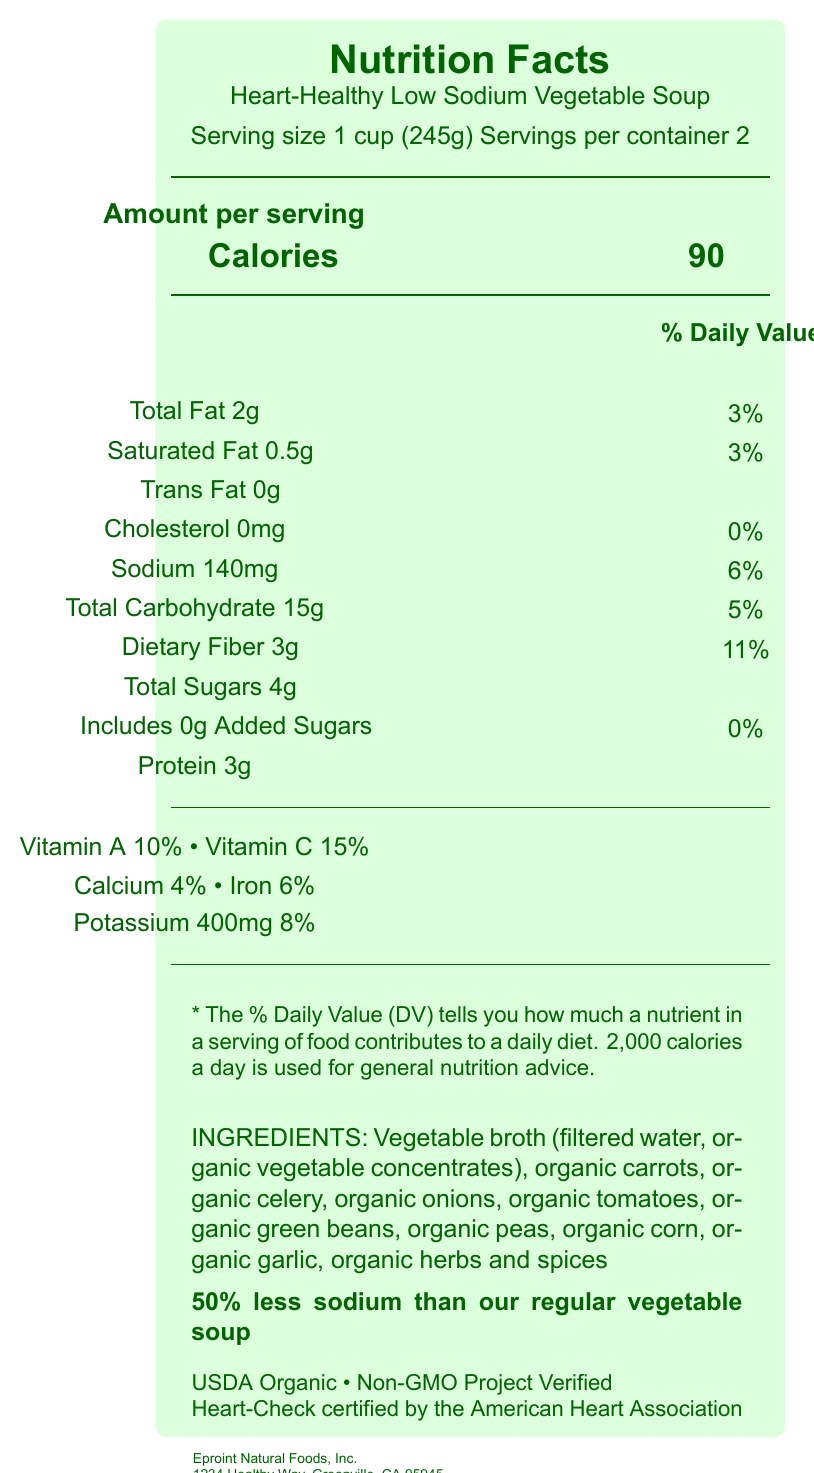what is the sodium content per serving? The document lists the sodium content as 140mg per serving.
Answer: 140mg how many servings are in the container? The document states that there are 2 servings per container.
Answer: 2 what is the percentage of the daily value of sodium per serving? The document indicates that the sodium content per serving is 140mg, which is 6% of the daily value.
Answer: 6% what are the first three ingredients listed? The ingredients list starts with vegetable broth, followed by organic carrots and organic celery.
Answer: Vegetable broth (filtered water, organic vegetable concentrates), Organic carrots, Organic celery how much protein is there per serving? The document lists the protein content as 3g per serving.
Answer: 3g how much total carbohydrate is there per serving? The document lists the total carbohydrate content as 15g per serving.
Answer: 15g does this product contain any known allergens? (Yes/No) The allergen statement in the document states that the product contains no known allergens.
Answer: No which of the following certifications does the product have? A. USDA Organic B. Fair Trade Certified C. Non-GMO Project Verified D. American Heart Association Heart-Check The document lists USDA Organic, Non-GMO Project Verified, and Heart-Check certified by the American Heart Association as certifications.
Answer: A, C, D for what reason might a consumer choose this soup over the regular version? A. Higher protein content B. Lower fat content C. Reduced sodium content D. Increased fiber content The comparative sodium statement mentions that this soup has 50% less sodium than the regular version.
Answer: C does the soup contain added sugars? (Yes/No) The document indicates "Includes 0g Added Sugars" with 0% daily value.
Answer: No how does the fiber content of this soup compare to typical dietary recommendations? The document states that the soup has 3g of dietary fiber per serving, which is 11% of the daily value, indicating it is relatively high.
Answer: It provides a relatively high proportion, 11%, of the daily recommended value per serving. is the total duration for which the fiber content of the soup contributes to your daily intake the same for all nutrients listed? (summary) While the fiber content contributes 11% per serving, the contributions of other nutrients vary: Total Fat (3%), Saturated Fat (3%), Cholesterol (0%), Sodium (6%), Total Carbohydrate (5%), Total Sugars and Added Sugars (0%), Protein (3g), Vitamin A (10%), Vitamin C (15%), Calcium (4%), Iron (6%), and Potassium (8%).
Answer: No how many calories from fat are in the soup? The document does not provide enough information to determine the calories derived specifically from fat.
Answer: Cannot be determined 